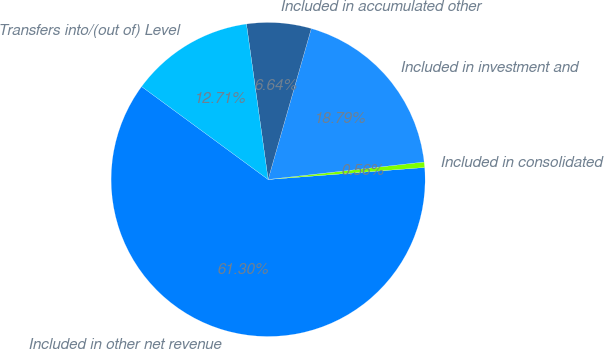Convert chart. <chart><loc_0><loc_0><loc_500><loc_500><pie_chart><fcel>Included in other net revenue<fcel>Included in consolidated<fcel>Included in investment and<fcel>Included in accumulated other<fcel>Transfers into/(out of) Level<nl><fcel>61.3%<fcel>0.56%<fcel>18.79%<fcel>6.64%<fcel>12.71%<nl></chart> 